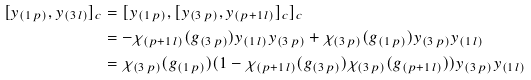Convert formula to latex. <formula><loc_0><loc_0><loc_500><loc_500>[ y _ { ( 1 \, p ) } , y _ { ( 3 \, l ) } ] _ { c } & = [ y _ { ( 1 \, p ) } , [ y _ { ( 3 \, p ) } , y _ { ( p + 1 \, l ) } ] _ { c } ] _ { c } \\ & = - \chi _ { ( p + 1 \, l ) } ( g _ { ( 3 \, p ) } ) y _ { ( 1 \, l ) } y _ { ( 3 \, p ) } + \chi _ { ( 3 \, p ) } ( g _ { ( 1 \, p ) } ) y _ { ( 3 \, p ) } y _ { ( 1 \, l ) } \\ & = \chi _ { ( 3 \, p ) } ( g _ { ( 1 \, p ) } ) ( 1 - \chi _ { ( p + 1 \, l ) } ( g _ { ( 3 \, p ) } ) \chi _ { ( 3 \, p ) } ( g _ { ( p + 1 \, l ) } ) ) y _ { ( 3 \, p ) } y _ { ( 1 \, l ) }</formula> 